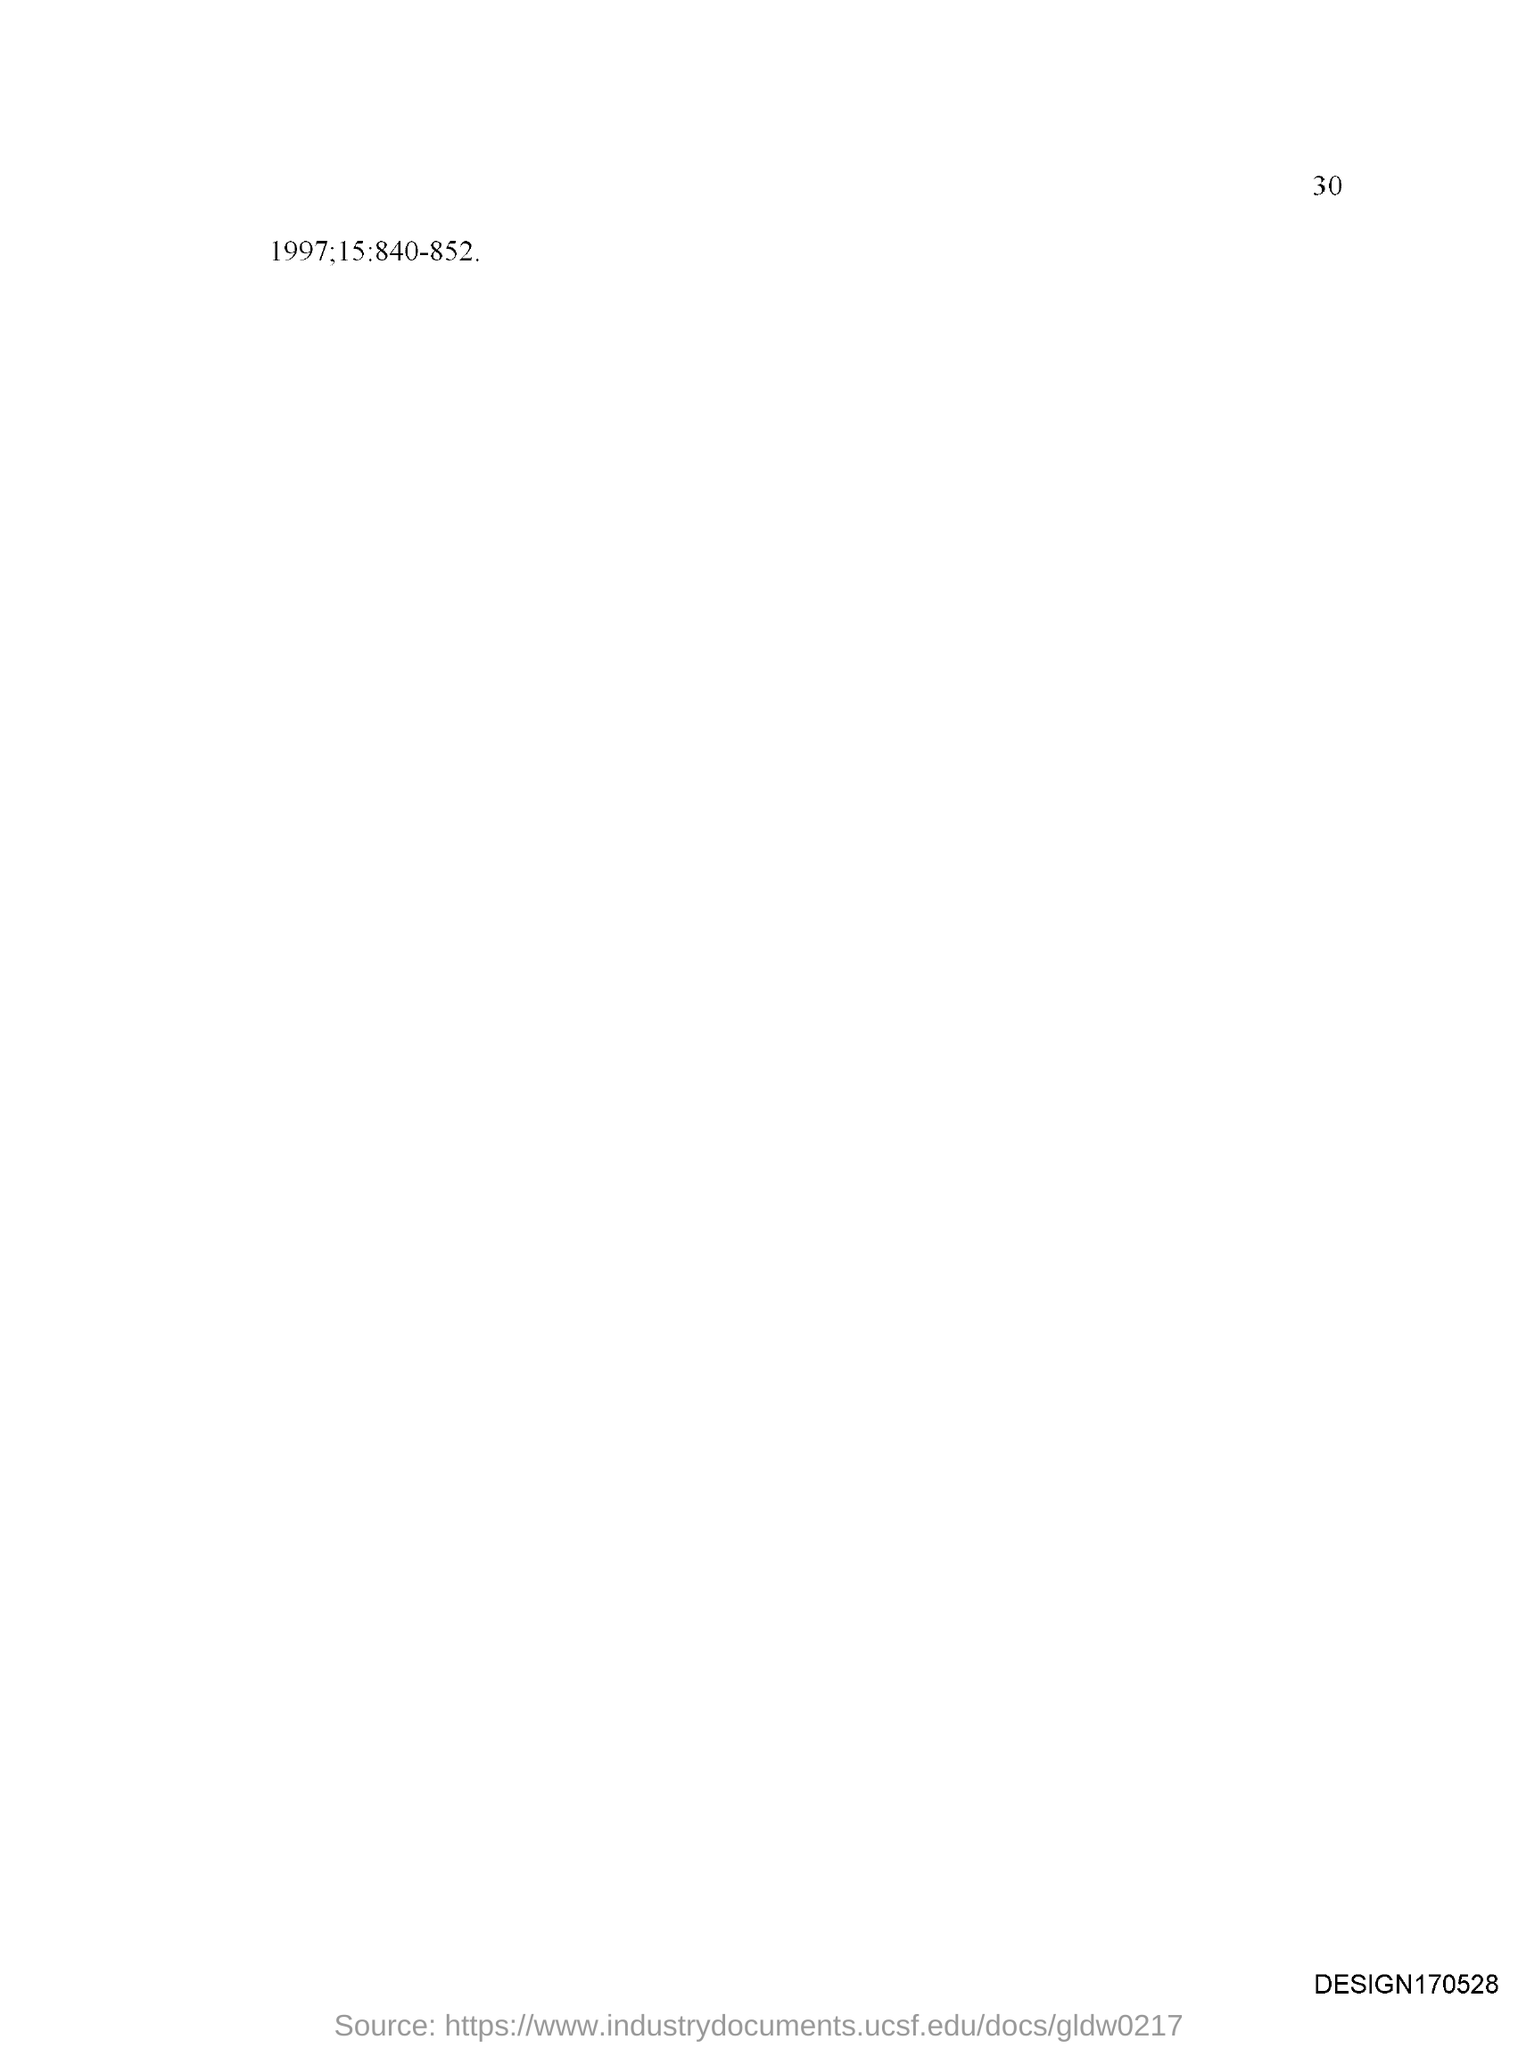What is the page number on this document?
Your response must be concise. 30. 